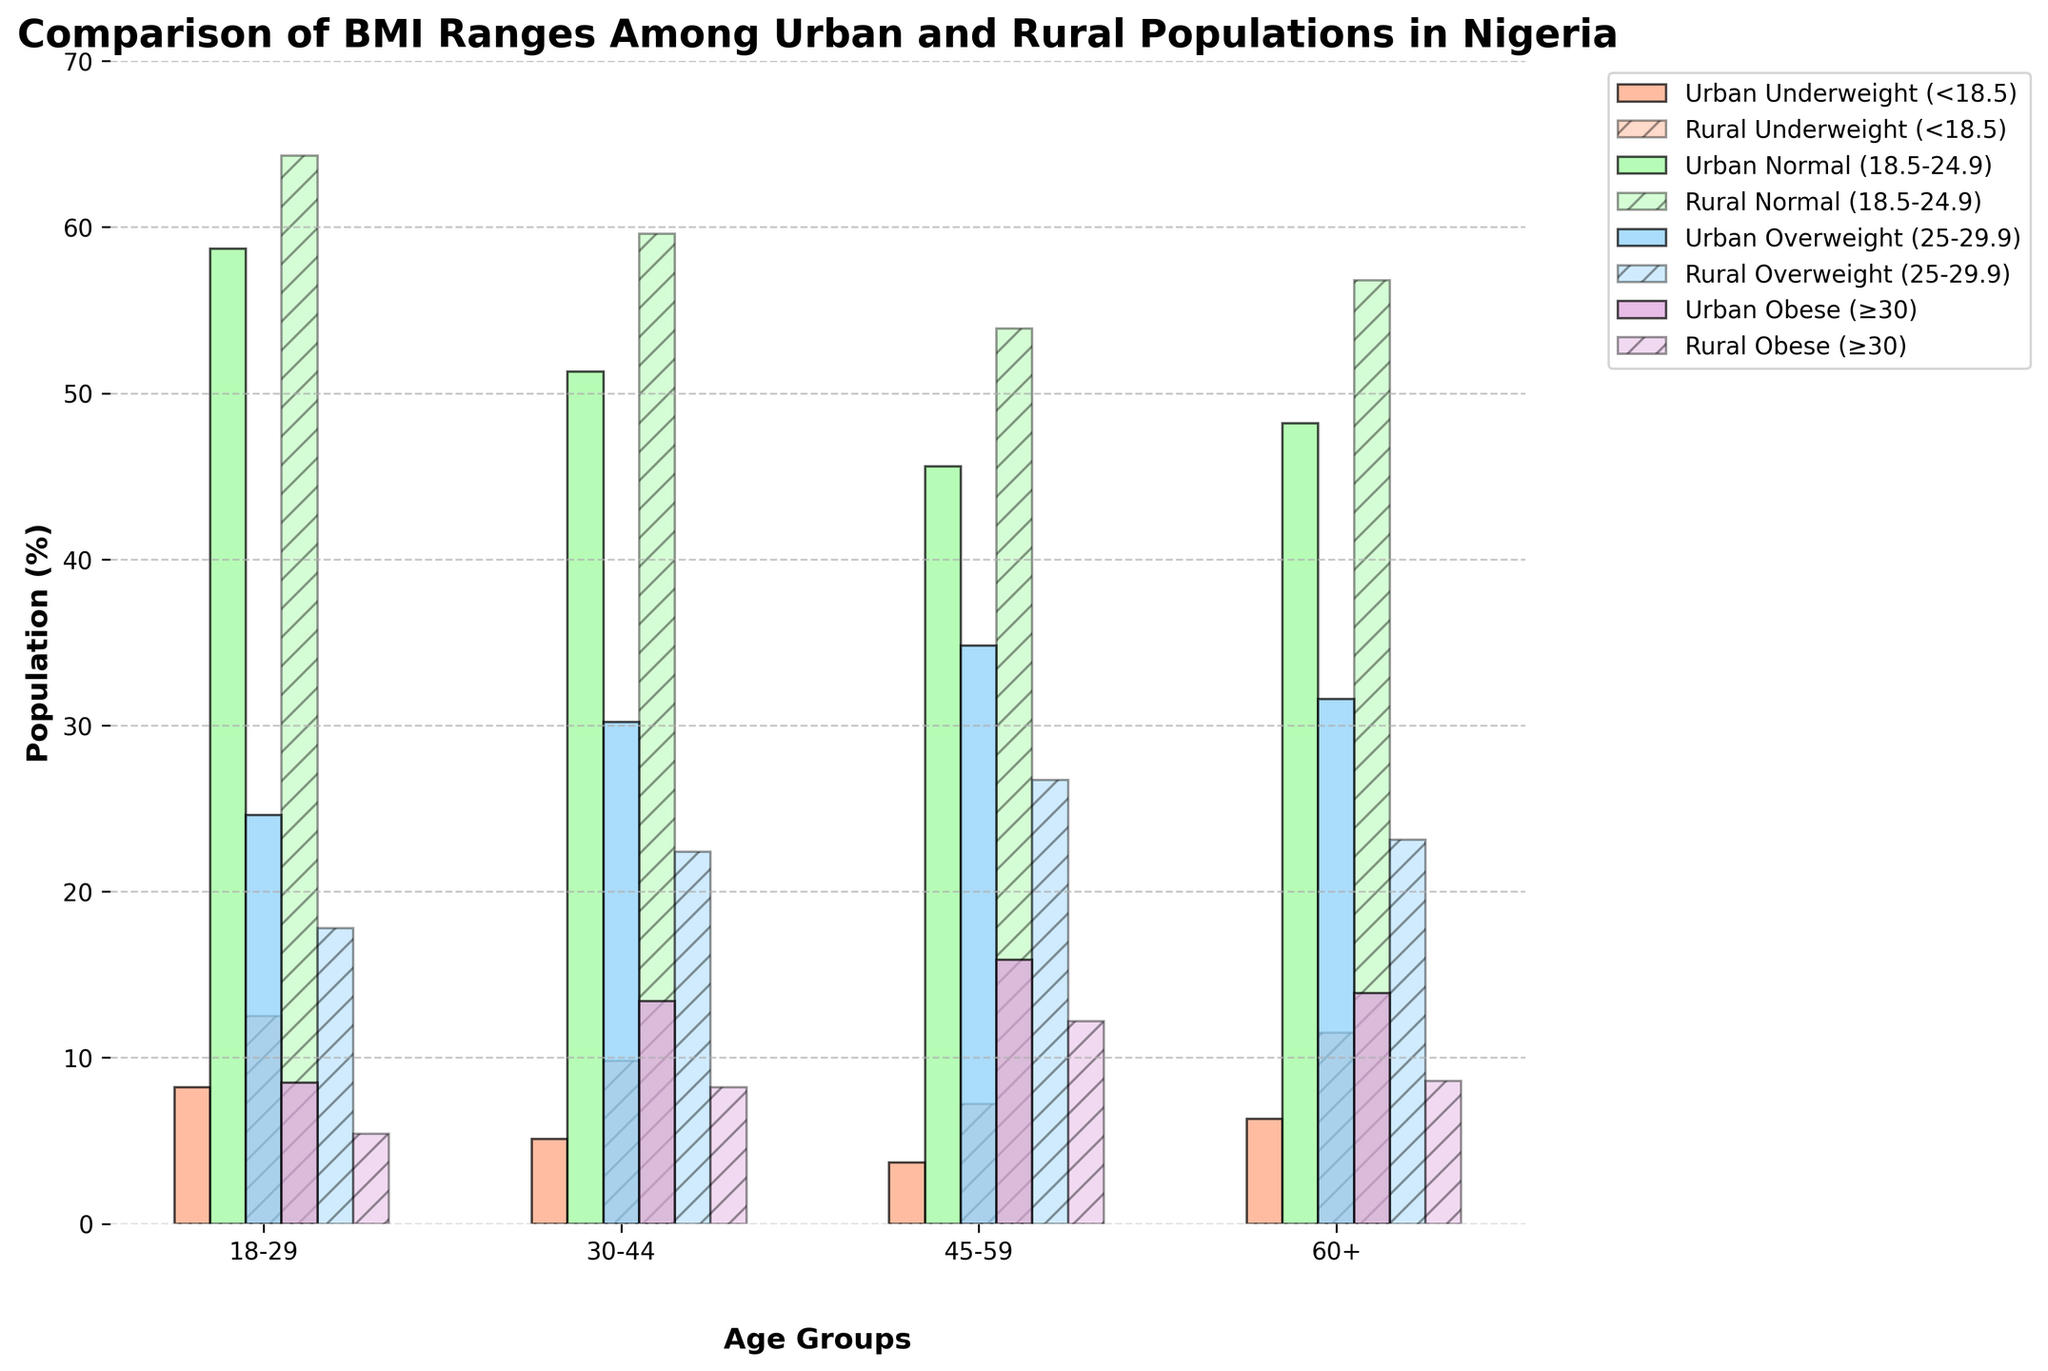What's the difference in the percentage of underweight individuals in the 18-29 age group between urban and rural populations? From the bar chart, the percentage of underweight individuals in urban areas for the 18-29 age group is 8.2%, and in rural areas, it is 12.5%. To find the difference, subtract the urban percentage from the rural percentage: 12.5% - 8.2% = 4.3%
Answer: 4.3% Which BMI range has the highest percentage in urban areas across all age groups? By examining the height/color of the bars representing urban areas across all age groups, it is clear that the "Normal (18.5-24.9)" BMI range has the highest percentages: 58.7%, 51.3%, 45.6%, and 48.2% respectively.
Answer: Normal (18.5-24.9) Which age group has the largest percentage of obese individuals in rural areas? Looking at the bars representing obese (≥30) individuals in rural areas across all age groups, the percentages are: 5.4% (18-29), 8.2% (30-44), 12.2% (45-59), and 8.6% (60+). The highest percentage is in the 45-59 age group.
Answer: 45-59 What's the average percentage of overweight individuals in rural areas across all age groups? The percentages of overweight individuals in rural areas for each age group are: 17.8%, 22.4%, 26.7%, and 23.1%. To find the average: (17.8% + 22.4% + 26.7% + 23.1%) / 4 = 22.5%
Answer: 22.5% Is the percentage of underweight individuals higher in urban or rural areas for the 30-44 age group? The bar chart shows that the percentage of underweight individuals in the 30-44 age group is 5.1% for urban areas and 9.8% for rural areas. Since 9.8% > 5.1%, the percentage is higher in rural areas.
Answer: Rural areas How does the percentage of overweight individuals in the 45-59 age group compare between urban and rural areas? The bar chart indicates the percentages of overweight individuals in the 45-59 age group as 34.8% for urban areas and 26.7% for rural areas. Thus, 34.8% > 26.7%, so the percentage is higher in urban areas.
Answer: Urban areas What is the total percentage of normal BMI range individuals in rural areas for the 18-29 and 30-44 age groups combined? For the 18-29 age group in rural areas, the percentage is 64.3%, and for the 30-44 age group, it is 59.6%. To find the total: 64.3% + 59.6% = 123.9%
Answer: 123.9% Which age group shows the smallest difference in the obese population between urban and rural areas? The differences in the obese population between urban and rural areas for each age group are: 
- 18-29: 8.5% - 5.4% = 3.1%
- 30-44: 13.4% - 8.2% = 5.2%
- 45-59: 15.9% - 12.2% = 3.7%
- 60+: 13.9% - 8.6% = 5.3%
The smallest difference is 3.1% for the 18-29 age group.
Answer: 18-29 In the 60+ age group, which BMI range has a higher percentage in rural areas compared to urban areas? For the 60+ age group, compare the bars for each BMI range:
- Underweight: 11.5% (rural) vs 6.3% (urban)
- Normal: 56.8% (rural) vs 48.2% (urban)
- Overweight, Obese: both have higher percentages in urban areas.
Thus, both "Underweight" and "Normal" BMI ranges have higher percentages in rural areas.
Answer: Underweight and Normal 